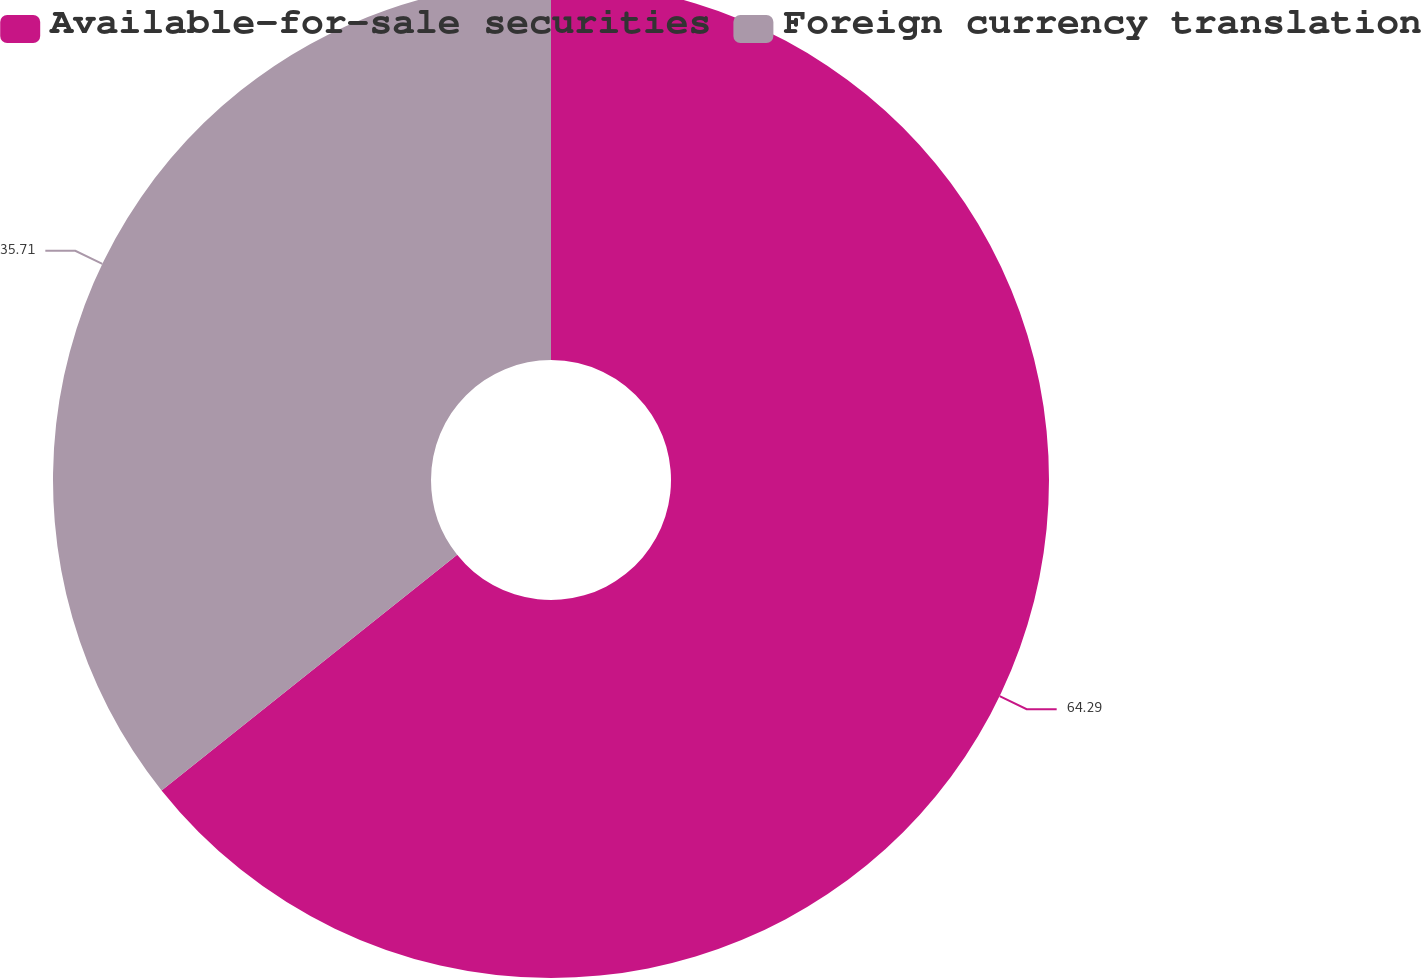Convert chart to OTSL. <chart><loc_0><loc_0><loc_500><loc_500><pie_chart><fcel>Available-for-sale securities<fcel>Foreign currency translation<nl><fcel>64.29%<fcel>35.71%<nl></chart> 